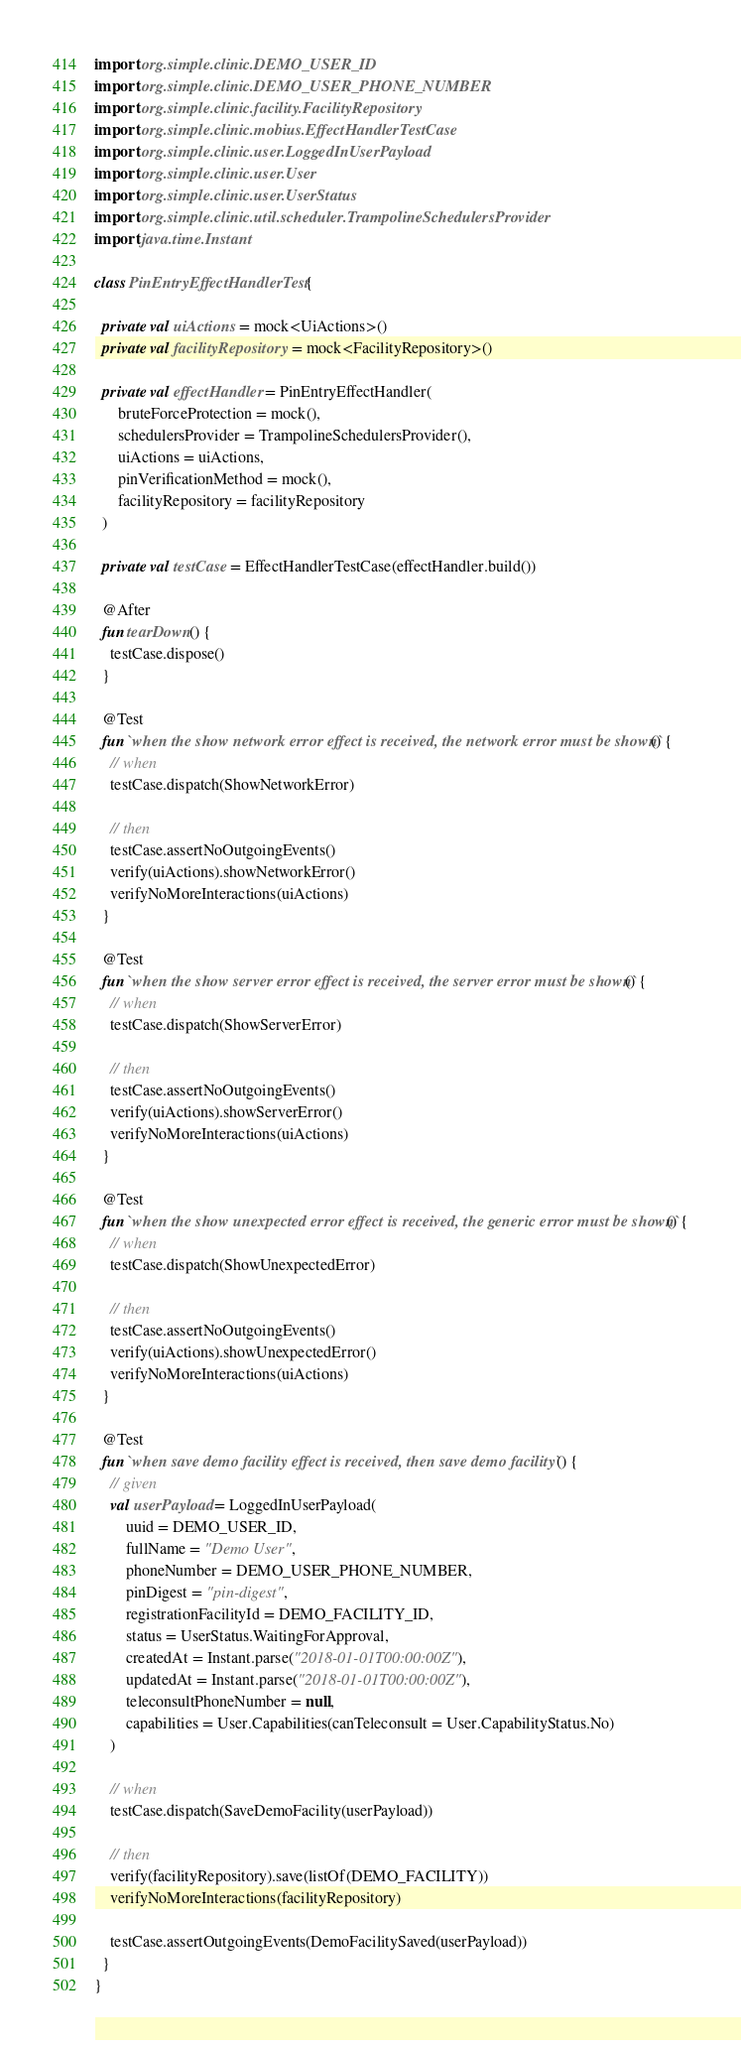<code> <loc_0><loc_0><loc_500><loc_500><_Kotlin_>import org.simple.clinic.DEMO_USER_ID
import org.simple.clinic.DEMO_USER_PHONE_NUMBER
import org.simple.clinic.facility.FacilityRepository
import org.simple.clinic.mobius.EffectHandlerTestCase
import org.simple.clinic.user.LoggedInUserPayload
import org.simple.clinic.user.User
import org.simple.clinic.user.UserStatus
import org.simple.clinic.util.scheduler.TrampolineSchedulersProvider
import java.time.Instant

class PinEntryEffectHandlerTest {

  private val uiActions = mock<UiActions>()
  private val facilityRepository = mock<FacilityRepository>()

  private val effectHandler = PinEntryEffectHandler(
      bruteForceProtection = mock(),
      schedulersProvider = TrampolineSchedulersProvider(),
      uiActions = uiActions,
      pinVerificationMethod = mock(),
      facilityRepository = facilityRepository
  )

  private val testCase = EffectHandlerTestCase(effectHandler.build())

  @After
  fun tearDown() {
    testCase.dispose()
  }

  @Test
  fun `when the show network error effect is received, the network error must be shown`() {
    // when
    testCase.dispatch(ShowNetworkError)

    // then
    testCase.assertNoOutgoingEvents()
    verify(uiActions).showNetworkError()
    verifyNoMoreInteractions(uiActions)
  }

  @Test
  fun `when the show server error effect is received, the server error must be shown`() {
    // when
    testCase.dispatch(ShowServerError)

    // then
    testCase.assertNoOutgoingEvents()
    verify(uiActions).showServerError()
    verifyNoMoreInteractions(uiActions)
  }

  @Test
  fun `when the show unexpected error effect is received, the generic error must be shown`() {
    // when
    testCase.dispatch(ShowUnexpectedError)

    // then
    testCase.assertNoOutgoingEvents()
    verify(uiActions).showUnexpectedError()
    verifyNoMoreInteractions(uiActions)
  }

  @Test
  fun `when save demo facility effect is received, then save demo facility`() {
    // given
    val userPayload = LoggedInUserPayload(
        uuid = DEMO_USER_ID,
        fullName = "Demo User",
        phoneNumber = DEMO_USER_PHONE_NUMBER,
        pinDigest = "pin-digest",
        registrationFacilityId = DEMO_FACILITY_ID,
        status = UserStatus.WaitingForApproval,
        createdAt = Instant.parse("2018-01-01T00:00:00Z"),
        updatedAt = Instant.parse("2018-01-01T00:00:00Z"),
        teleconsultPhoneNumber = null,
        capabilities = User.Capabilities(canTeleconsult = User.CapabilityStatus.No)
    )

    // when
    testCase.dispatch(SaveDemoFacility(userPayload))

    // then
    verify(facilityRepository).save(listOf(DEMO_FACILITY))
    verifyNoMoreInteractions(facilityRepository)

    testCase.assertOutgoingEvents(DemoFacilitySaved(userPayload))
  }
}
</code> 